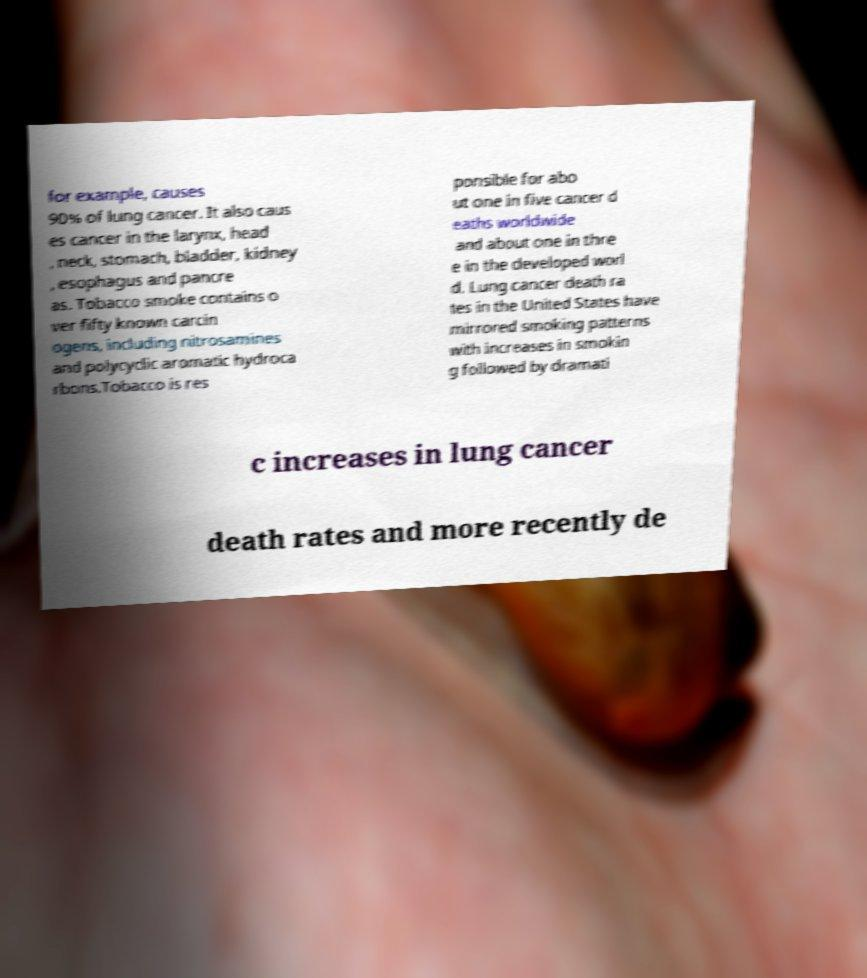What messages or text are displayed in this image? I need them in a readable, typed format. for example, causes 90% of lung cancer. It also caus es cancer in the larynx, head , neck, stomach, bladder, kidney , esophagus and pancre as. Tobacco smoke contains o ver fifty known carcin ogens, including nitrosamines and polycyclic aromatic hydroca rbons.Tobacco is res ponsible for abo ut one in five cancer d eaths worldwide and about one in thre e in the developed worl d. Lung cancer death ra tes in the United States have mirrored smoking patterns with increases in smokin g followed by dramati c increases in lung cancer death rates and more recently de 